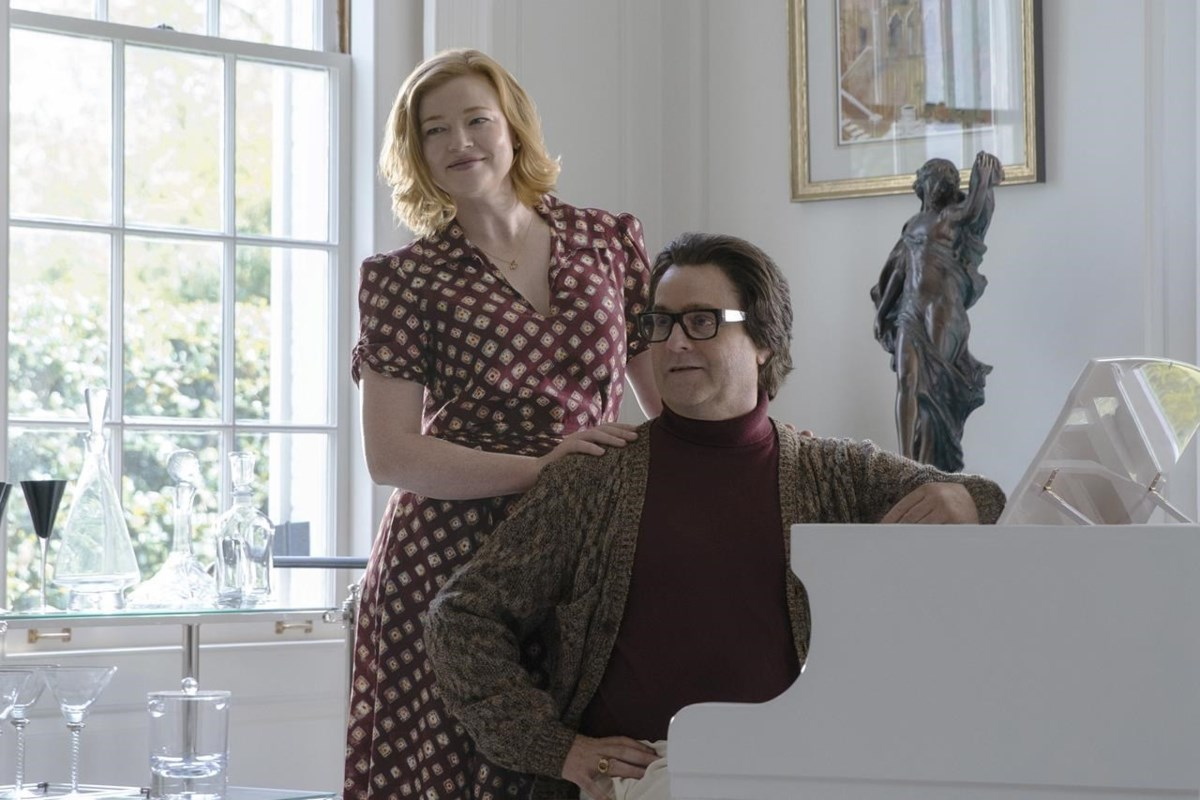What are the key elements in this picture? In this image, we observe a scene from the movie "Youth in Oregon". The photograph features two actors. One actor is seated at a white piano, wearing a red sweater and a patterned brown cardigan, seemingly in a cheerful mood. Another actor stands behind him, with a hand resting gently on his shoulder, contributing to the warm and happy atmosphere. The setting is a bright room with a large window draped with white curtains. On the wall, there is a framed picture, and a statue of a lady is elegantly positioned on a pedestal, adding to the sophisticated environment. 